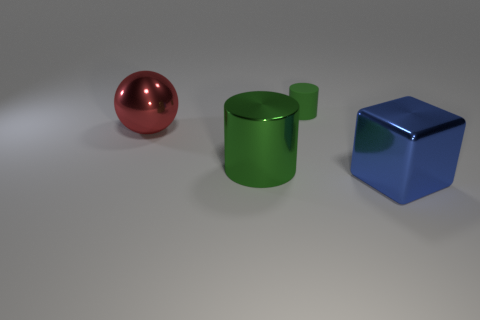What number of things are shiny balls or big things right of the sphere? There is one shiny ball, which is the red sphere on the left. To the right of the sphere, there are two larger objects: a green cylinder and a blue cube. So, in total, there are three items if we count the shiny ball and the bigger things to its right. 